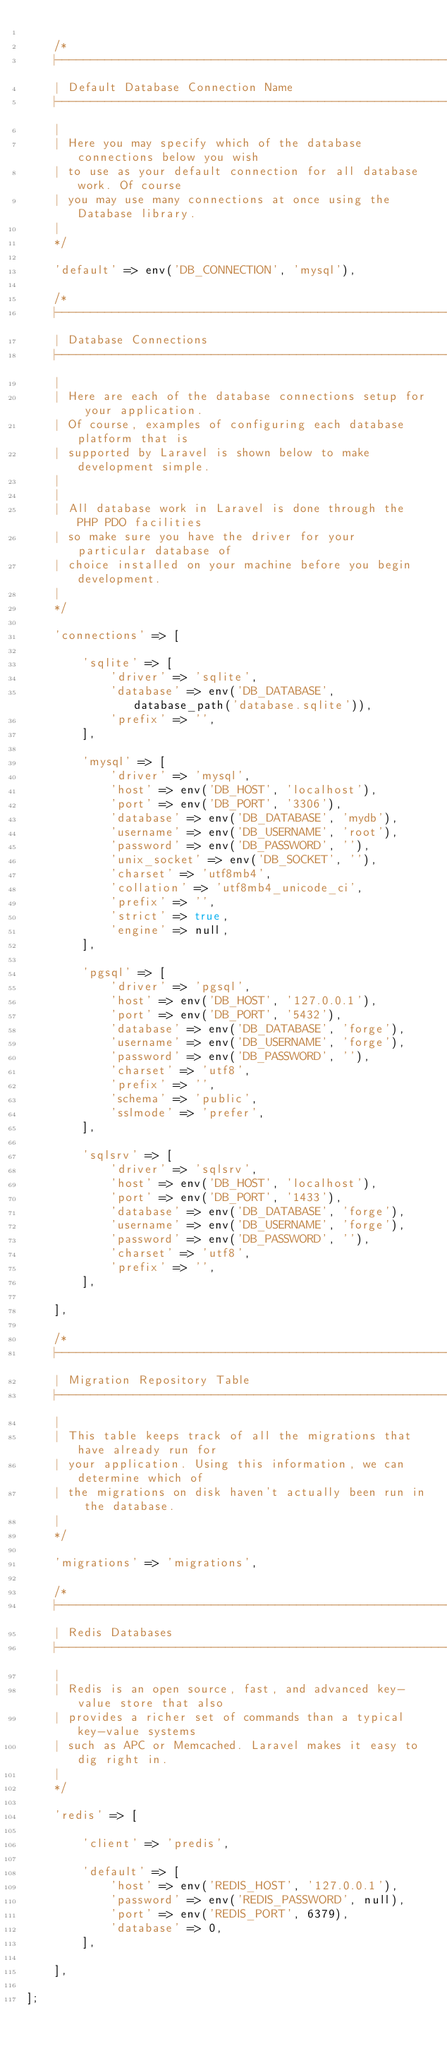<code> <loc_0><loc_0><loc_500><loc_500><_PHP_>
    /*
    |--------------------------------------------------------------------------
    | Default Database Connection Name
    |--------------------------------------------------------------------------
    |
    | Here you may specify which of the database connections below you wish
    | to use as your default connection for all database work. Of course
    | you may use many connections at once using the Database library.
    |
    */

    'default' => env('DB_CONNECTION', 'mysql'),

    /*
    |--------------------------------------------------------------------------
    | Database Connections
    |--------------------------------------------------------------------------
    |
    | Here are each of the database connections setup for your application.
    | Of course, examples of configuring each database platform that is
    | supported by Laravel is shown below to make development simple.
    |
    |
    | All database work in Laravel is done through the PHP PDO facilities
    | so make sure you have the driver for your particular database of
    | choice installed on your machine before you begin development.
    |
    */

    'connections' => [

        'sqlite' => [
            'driver' => 'sqlite',
            'database' => env('DB_DATABASE', database_path('database.sqlite')),
            'prefix' => '',
        ],

        'mysql' => [
            'driver' => 'mysql',
            'host' => env('DB_HOST', 'localhost'),
            'port' => env('DB_PORT', '3306'),
            'database' => env('DB_DATABASE', 'mydb'),
            'username' => env('DB_USERNAME', 'root'),
            'password' => env('DB_PASSWORD', ''),
            'unix_socket' => env('DB_SOCKET', ''),
            'charset' => 'utf8mb4',
            'collation' => 'utf8mb4_unicode_ci',
            'prefix' => '',
            'strict' => true,
            'engine' => null,
        ],

        'pgsql' => [
            'driver' => 'pgsql',
            'host' => env('DB_HOST', '127.0.0.1'),
            'port' => env('DB_PORT', '5432'),
            'database' => env('DB_DATABASE', 'forge'),
            'username' => env('DB_USERNAME', 'forge'),
            'password' => env('DB_PASSWORD', ''),
            'charset' => 'utf8',
            'prefix' => '',
            'schema' => 'public',
            'sslmode' => 'prefer',
        ],

        'sqlsrv' => [
            'driver' => 'sqlsrv',
            'host' => env('DB_HOST', 'localhost'),
            'port' => env('DB_PORT', '1433'),
            'database' => env('DB_DATABASE', 'forge'),
            'username' => env('DB_USERNAME', 'forge'),
            'password' => env('DB_PASSWORD', ''),
            'charset' => 'utf8',
            'prefix' => '',
        ],

    ],

    /*
    |--------------------------------------------------------------------------
    | Migration Repository Table
    |--------------------------------------------------------------------------
    |
    | This table keeps track of all the migrations that have already run for
    | your application. Using this information, we can determine which of
    | the migrations on disk haven't actually been run in the database.
    |
    */

    'migrations' => 'migrations',

    /*
    |--------------------------------------------------------------------------
    | Redis Databases
    |--------------------------------------------------------------------------
    |
    | Redis is an open source, fast, and advanced key-value store that also
    | provides a richer set of commands than a typical key-value systems
    | such as APC or Memcached. Laravel makes it easy to dig right in.
    |
    */

    'redis' => [

        'client' => 'predis',

        'default' => [
            'host' => env('REDIS_HOST', '127.0.0.1'),
            'password' => env('REDIS_PASSWORD', null),
            'port' => env('REDIS_PORT', 6379),
            'database' => 0,
        ],

    ],

];
</code> 